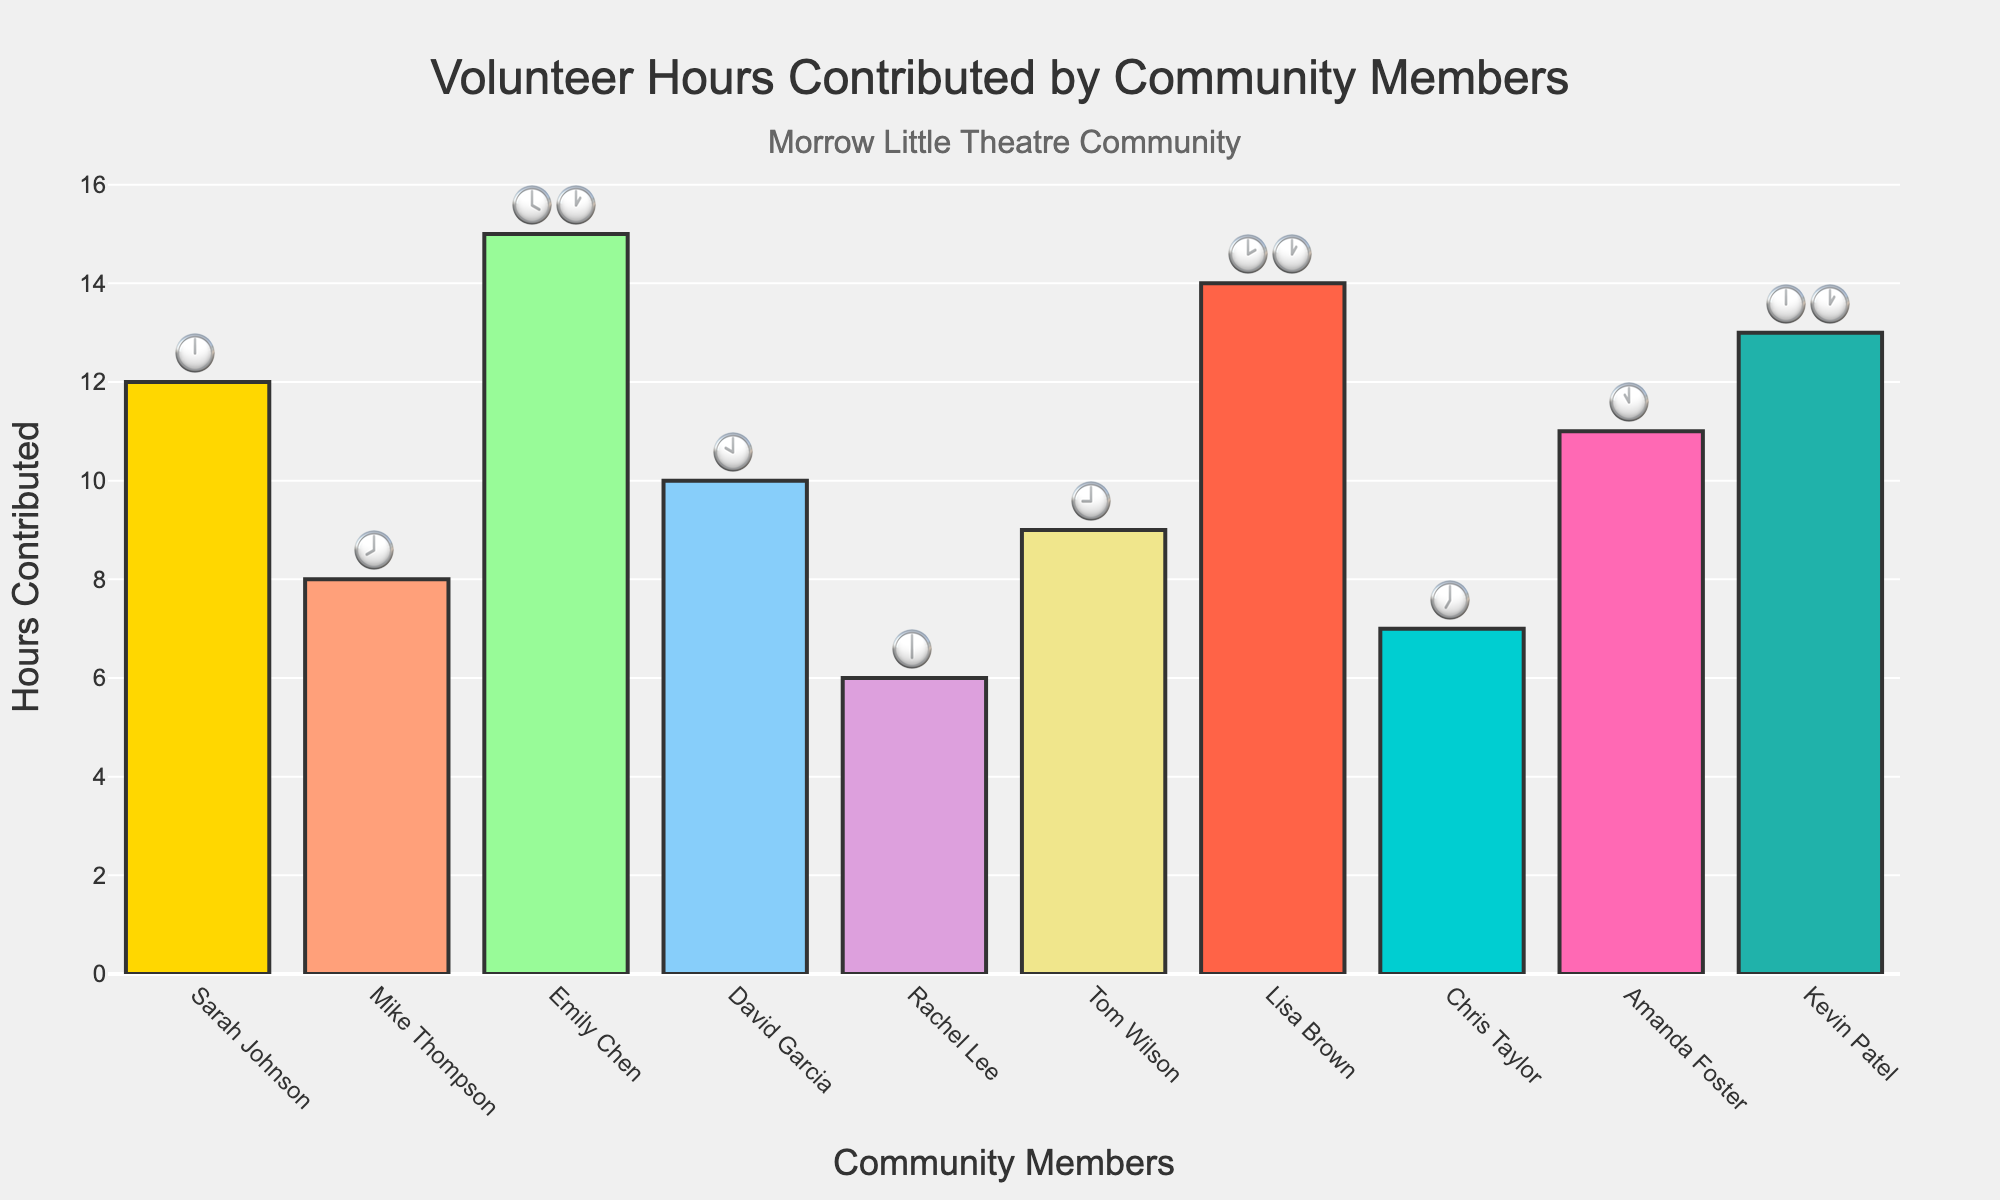Which actor contributed the most volunteer hours? The actor with the highest bar in the chart represents the most hours. Emily Chen has the tallest bar indicating 15 hours.
Answer: Emily Chen How many hours did Rachel Lee contribute? Find Rachel Lee's bar on the x-axis and look at its height or value text. It is 6 hours.
Answer: 6 hours What is the total volunteer hours contributed by Sarah Johnson and Mike Thompson? Sarah Johnson contributed 12 hours and Mike Thompson contributed 8 hours. Adding them gives 12 + 8 = 20 hours.
Answer: 20 hours Which two actors have contributed exactly the same number of hours? By examining the heights of the bars or values, Kevin Patel and Sarah Johnson both contribute 12 hours each.
Answer: Kevin Patel and Sarah Johnson How much more did Chris Taylor contribute compared to Rachel Lee? Chris Taylor contributed 7 hours and Rachel Lee contributed 6 hours. The difference is 7 - 6 = 1 hour.
Answer: 1 hour What is the average number of hours contributed by all actors? Sum all the hours and divide by the number of actors. (12+8+15+10+6+9+14+7+11+13)/10 = 105/10 = 10.5 hours.
Answer: 10.5 hours Who contributed the second-highest number of hours? Find the second tallest bar. Lisa Brown contributed 14 hours, which is the second highest.
Answer: Lisa Brown How many clock emojis (total) are used in the chart? Sum the individual emojis from the table. Sarah:1, Mike:1, Emily:2, David:1, Rachel:1, Tom:1, Lisa:2, Chris:1, Amanda:1, Kevin:2. Total = 13.
Answer: 13 emojis Which actors contributed more than 10 hours? Identify bars taller than 10 hours. They are Emily Chen (15), Lisa Brown (14), Kevin Patel (13), Amanda Foster (11), and Sarah Johnson (12).
Answer: Emily Chen, Lisa Brown, Kevin Patel, Amanda Foster, Sarah Johnson What is the range of volunteer hours contributed? The range is the difference between the maximum and minimum values. Maximum is 15 hours (Emily Chen) and minimum is 6 hours (Rachel Lee). Range = 15 - 6 = 9 hours.
Answer: 9 hours 